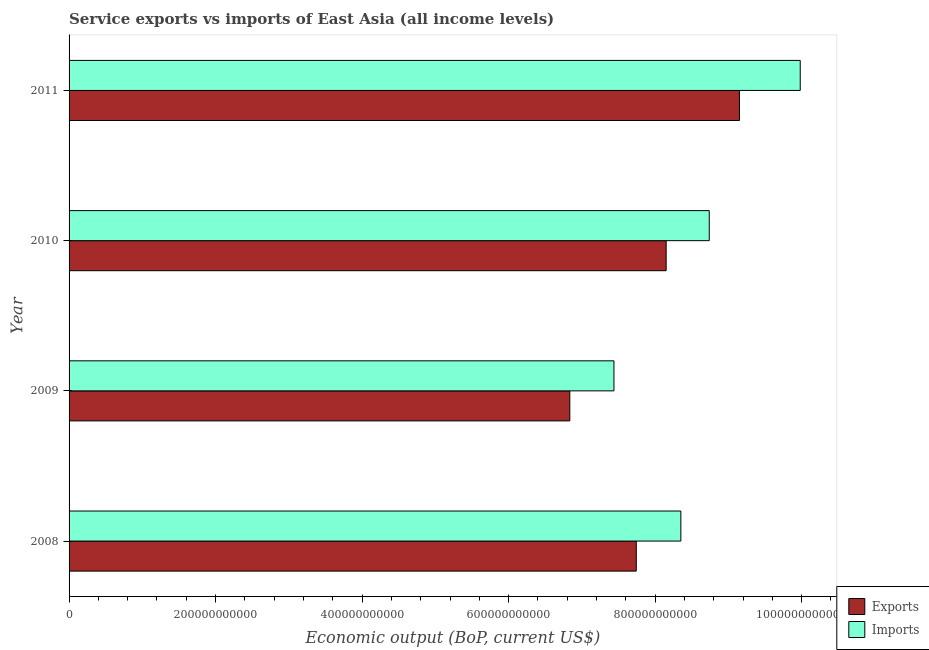Are the number of bars per tick equal to the number of legend labels?
Ensure brevity in your answer.  Yes. What is the label of the 4th group of bars from the top?
Your answer should be compact. 2008. In how many cases, is the number of bars for a given year not equal to the number of legend labels?
Provide a short and direct response. 0. What is the amount of service exports in 2011?
Offer a terse response. 9.15e+11. Across all years, what is the maximum amount of service exports?
Ensure brevity in your answer.  9.15e+11. Across all years, what is the minimum amount of service exports?
Make the answer very short. 6.84e+11. What is the total amount of service imports in the graph?
Provide a succinct answer. 3.45e+12. What is the difference between the amount of service imports in 2010 and that in 2011?
Ensure brevity in your answer.  -1.24e+11. What is the difference between the amount of service exports in 2011 and the amount of service imports in 2009?
Keep it short and to the point. 1.71e+11. What is the average amount of service imports per year?
Your answer should be very brief. 8.63e+11. In the year 2011, what is the difference between the amount of service exports and amount of service imports?
Keep it short and to the point. -8.30e+1. In how many years, is the amount of service exports greater than 200000000000 US$?
Your answer should be very brief. 4. What is the ratio of the amount of service imports in 2010 to that in 2011?
Provide a succinct answer. 0.88. What is the difference between the highest and the second highest amount of service exports?
Your answer should be compact. 1.00e+11. What is the difference between the highest and the lowest amount of service imports?
Your answer should be compact. 2.54e+11. What does the 2nd bar from the top in 2008 represents?
Provide a short and direct response. Exports. What does the 2nd bar from the bottom in 2008 represents?
Offer a terse response. Imports. How many years are there in the graph?
Make the answer very short. 4. What is the difference between two consecutive major ticks on the X-axis?
Your answer should be very brief. 2.00e+11. Does the graph contain grids?
Offer a very short reply. No. How many legend labels are there?
Keep it short and to the point. 2. What is the title of the graph?
Offer a very short reply. Service exports vs imports of East Asia (all income levels). What is the label or title of the X-axis?
Your answer should be compact. Economic output (BoP, current US$). What is the Economic output (BoP, current US$) of Exports in 2008?
Offer a terse response. 7.74e+11. What is the Economic output (BoP, current US$) of Imports in 2008?
Your answer should be very brief. 8.35e+11. What is the Economic output (BoP, current US$) in Exports in 2009?
Offer a very short reply. 6.84e+11. What is the Economic output (BoP, current US$) in Imports in 2009?
Keep it short and to the point. 7.44e+11. What is the Economic output (BoP, current US$) of Exports in 2010?
Provide a short and direct response. 8.15e+11. What is the Economic output (BoP, current US$) in Imports in 2010?
Your answer should be very brief. 8.74e+11. What is the Economic output (BoP, current US$) in Exports in 2011?
Your answer should be very brief. 9.15e+11. What is the Economic output (BoP, current US$) in Imports in 2011?
Keep it short and to the point. 9.98e+11. Across all years, what is the maximum Economic output (BoP, current US$) of Exports?
Your response must be concise. 9.15e+11. Across all years, what is the maximum Economic output (BoP, current US$) of Imports?
Give a very brief answer. 9.98e+11. Across all years, what is the minimum Economic output (BoP, current US$) of Exports?
Your answer should be very brief. 6.84e+11. Across all years, what is the minimum Economic output (BoP, current US$) of Imports?
Ensure brevity in your answer.  7.44e+11. What is the total Economic output (BoP, current US$) in Exports in the graph?
Provide a succinct answer. 3.19e+12. What is the total Economic output (BoP, current US$) of Imports in the graph?
Offer a terse response. 3.45e+12. What is the difference between the Economic output (BoP, current US$) in Exports in 2008 and that in 2009?
Make the answer very short. 9.07e+1. What is the difference between the Economic output (BoP, current US$) in Imports in 2008 and that in 2009?
Give a very brief answer. 9.13e+1. What is the difference between the Economic output (BoP, current US$) of Exports in 2008 and that in 2010?
Your answer should be compact. -4.08e+1. What is the difference between the Economic output (BoP, current US$) in Imports in 2008 and that in 2010?
Make the answer very short. -3.88e+1. What is the difference between the Economic output (BoP, current US$) in Exports in 2008 and that in 2011?
Your answer should be very brief. -1.41e+11. What is the difference between the Economic output (BoP, current US$) in Imports in 2008 and that in 2011?
Give a very brief answer. -1.63e+11. What is the difference between the Economic output (BoP, current US$) of Exports in 2009 and that in 2010?
Your response must be concise. -1.31e+11. What is the difference between the Economic output (BoP, current US$) of Imports in 2009 and that in 2010?
Keep it short and to the point. -1.30e+11. What is the difference between the Economic output (BoP, current US$) of Exports in 2009 and that in 2011?
Keep it short and to the point. -2.32e+11. What is the difference between the Economic output (BoP, current US$) in Imports in 2009 and that in 2011?
Your response must be concise. -2.54e+11. What is the difference between the Economic output (BoP, current US$) of Exports in 2010 and that in 2011?
Provide a succinct answer. -1.00e+11. What is the difference between the Economic output (BoP, current US$) in Imports in 2010 and that in 2011?
Provide a succinct answer. -1.24e+11. What is the difference between the Economic output (BoP, current US$) in Exports in 2008 and the Economic output (BoP, current US$) in Imports in 2009?
Your answer should be compact. 3.05e+1. What is the difference between the Economic output (BoP, current US$) in Exports in 2008 and the Economic output (BoP, current US$) in Imports in 2010?
Provide a short and direct response. -9.96e+1. What is the difference between the Economic output (BoP, current US$) in Exports in 2008 and the Economic output (BoP, current US$) in Imports in 2011?
Provide a succinct answer. -2.24e+11. What is the difference between the Economic output (BoP, current US$) of Exports in 2009 and the Economic output (BoP, current US$) of Imports in 2010?
Provide a short and direct response. -1.90e+11. What is the difference between the Economic output (BoP, current US$) of Exports in 2009 and the Economic output (BoP, current US$) of Imports in 2011?
Your answer should be very brief. -3.15e+11. What is the difference between the Economic output (BoP, current US$) of Exports in 2010 and the Economic output (BoP, current US$) of Imports in 2011?
Provide a short and direct response. -1.83e+11. What is the average Economic output (BoP, current US$) in Exports per year?
Provide a short and direct response. 7.97e+11. What is the average Economic output (BoP, current US$) in Imports per year?
Offer a very short reply. 8.63e+11. In the year 2008, what is the difference between the Economic output (BoP, current US$) of Exports and Economic output (BoP, current US$) of Imports?
Your answer should be compact. -6.08e+1. In the year 2009, what is the difference between the Economic output (BoP, current US$) in Exports and Economic output (BoP, current US$) in Imports?
Keep it short and to the point. -6.02e+1. In the year 2010, what is the difference between the Economic output (BoP, current US$) of Exports and Economic output (BoP, current US$) of Imports?
Offer a very short reply. -5.88e+1. In the year 2011, what is the difference between the Economic output (BoP, current US$) of Exports and Economic output (BoP, current US$) of Imports?
Your response must be concise. -8.30e+1. What is the ratio of the Economic output (BoP, current US$) in Exports in 2008 to that in 2009?
Offer a terse response. 1.13. What is the ratio of the Economic output (BoP, current US$) of Imports in 2008 to that in 2009?
Provide a succinct answer. 1.12. What is the ratio of the Economic output (BoP, current US$) in Imports in 2008 to that in 2010?
Keep it short and to the point. 0.96. What is the ratio of the Economic output (BoP, current US$) in Exports in 2008 to that in 2011?
Your response must be concise. 0.85. What is the ratio of the Economic output (BoP, current US$) in Imports in 2008 to that in 2011?
Provide a short and direct response. 0.84. What is the ratio of the Economic output (BoP, current US$) in Exports in 2009 to that in 2010?
Provide a succinct answer. 0.84. What is the ratio of the Economic output (BoP, current US$) in Imports in 2009 to that in 2010?
Offer a terse response. 0.85. What is the ratio of the Economic output (BoP, current US$) in Exports in 2009 to that in 2011?
Offer a very short reply. 0.75. What is the ratio of the Economic output (BoP, current US$) of Imports in 2009 to that in 2011?
Your answer should be very brief. 0.75. What is the ratio of the Economic output (BoP, current US$) in Exports in 2010 to that in 2011?
Your answer should be very brief. 0.89. What is the ratio of the Economic output (BoP, current US$) of Imports in 2010 to that in 2011?
Offer a very short reply. 0.88. What is the difference between the highest and the second highest Economic output (BoP, current US$) in Exports?
Keep it short and to the point. 1.00e+11. What is the difference between the highest and the second highest Economic output (BoP, current US$) of Imports?
Your response must be concise. 1.24e+11. What is the difference between the highest and the lowest Economic output (BoP, current US$) in Exports?
Your answer should be compact. 2.32e+11. What is the difference between the highest and the lowest Economic output (BoP, current US$) of Imports?
Provide a succinct answer. 2.54e+11. 